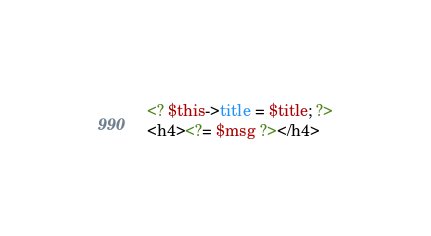Convert code to text. <code><loc_0><loc_0><loc_500><loc_500><_PHP_><? $this->title = $title; ?>
<h4><?= $msg ?></h4>

</code> 